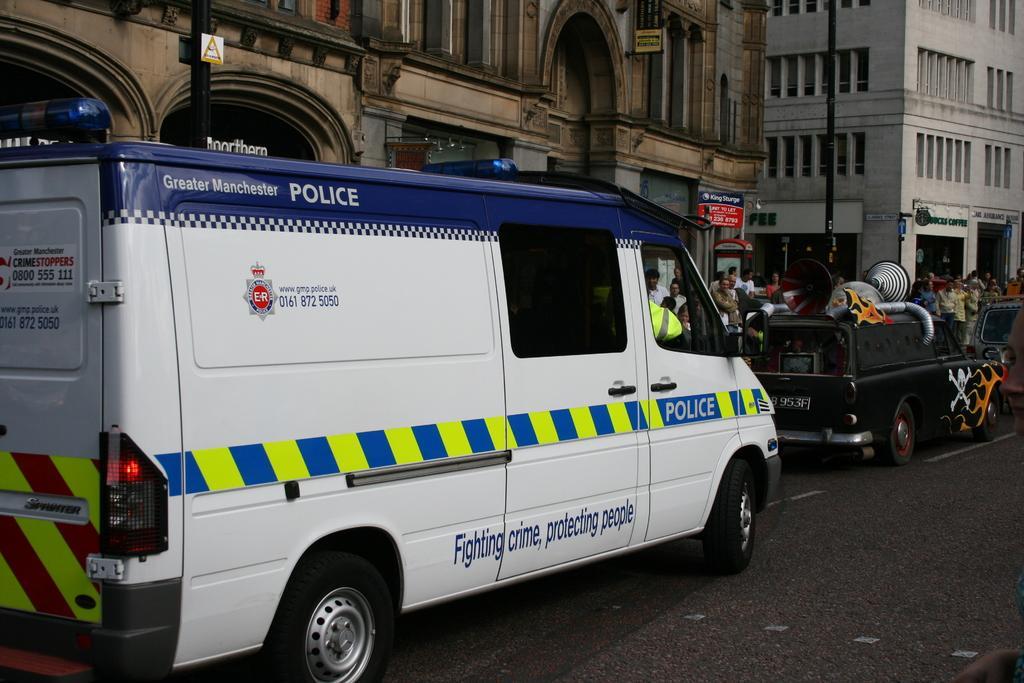Can you describe this image briefly? Vehicles are on the road. Background there are buildings, signboards, poles, people and windows. 